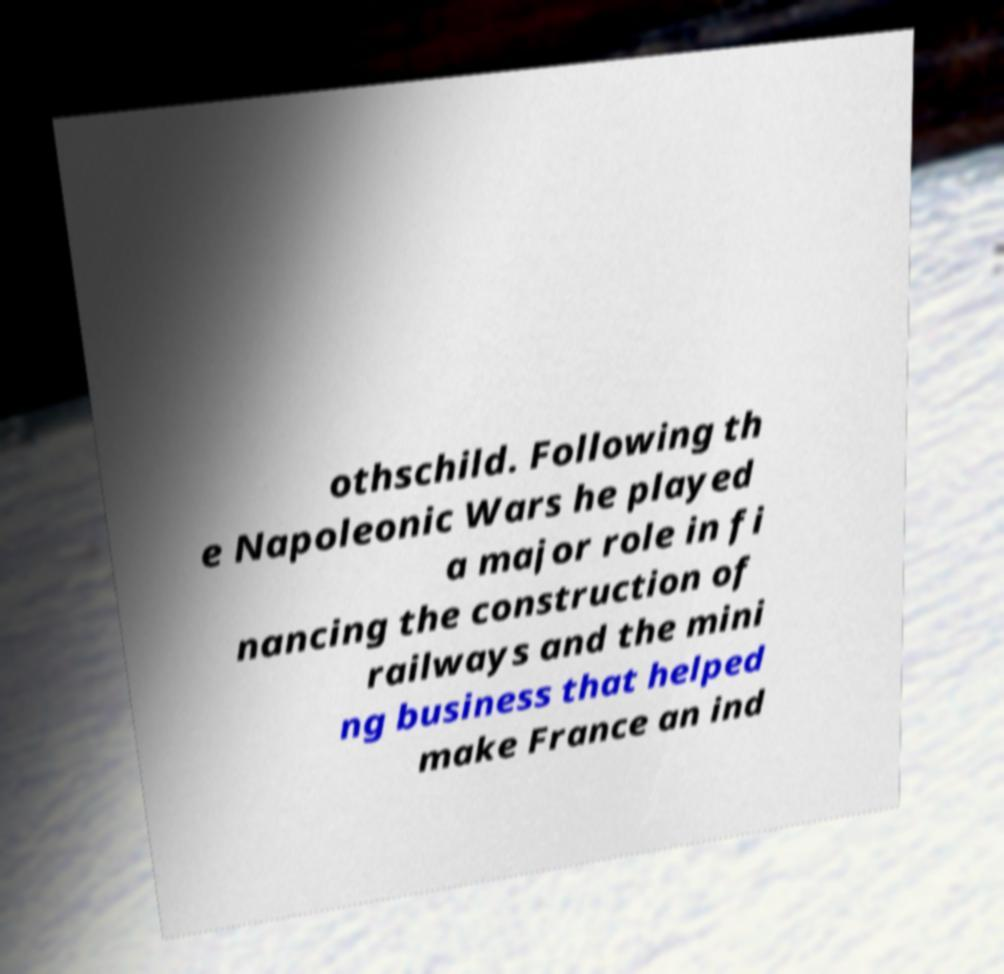What messages or text are displayed in this image? I need them in a readable, typed format. othschild. Following th e Napoleonic Wars he played a major role in fi nancing the construction of railways and the mini ng business that helped make France an ind 